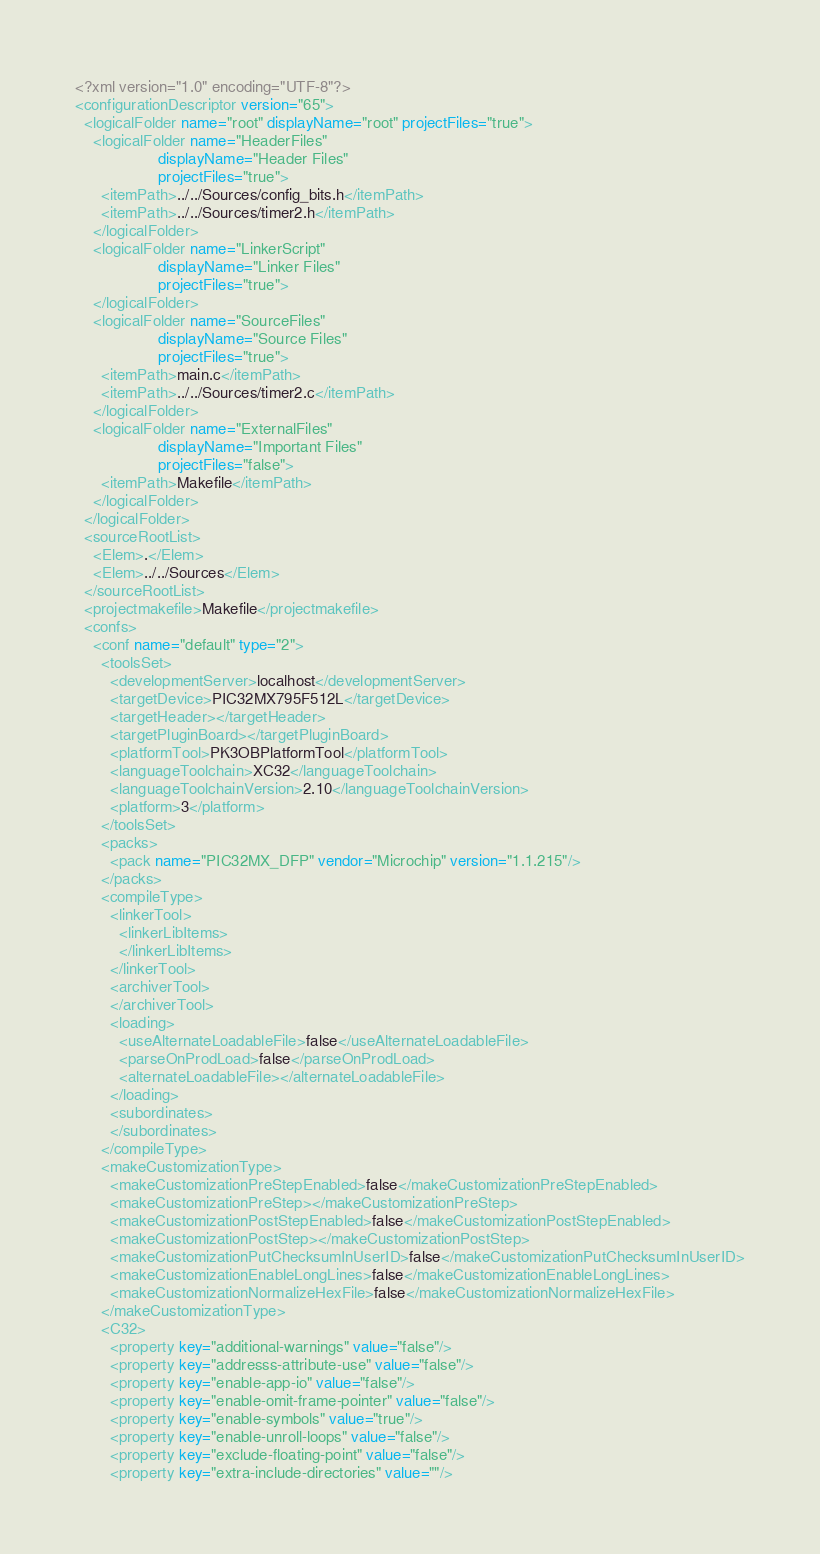<code> <loc_0><loc_0><loc_500><loc_500><_XML_><?xml version="1.0" encoding="UTF-8"?>
<configurationDescriptor version="65">
  <logicalFolder name="root" displayName="root" projectFiles="true">
    <logicalFolder name="HeaderFiles"
                   displayName="Header Files"
                   projectFiles="true">
      <itemPath>../../Sources/config_bits.h</itemPath>
      <itemPath>../../Sources/timer2.h</itemPath>
    </logicalFolder>
    <logicalFolder name="LinkerScript"
                   displayName="Linker Files"
                   projectFiles="true">
    </logicalFolder>
    <logicalFolder name="SourceFiles"
                   displayName="Source Files"
                   projectFiles="true">
      <itemPath>main.c</itemPath>
      <itemPath>../../Sources/timer2.c</itemPath>
    </logicalFolder>
    <logicalFolder name="ExternalFiles"
                   displayName="Important Files"
                   projectFiles="false">
      <itemPath>Makefile</itemPath>
    </logicalFolder>
  </logicalFolder>
  <sourceRootList>
    <Elem>.</Elem>
    <Elem>../../Sources</Elem>
  </sourceRootList>
  <projectmakefile>Makefile</projectmakefile>
  <confs>
    <conf name="default" type="2">
      <toolsSet>
        <developmentServer>localhost</developmentServer>
        <targetDevice>PIC32MX795F512L</targetDevice>
        <targetHeader></targetHeader>
        <targetPluginBoard></targetPluginBoard>
        <platformTool>PK3OBPlatformTool</platformTool>
        <languageToolchain>XC32</languageToolchain>
        <languageToolchainVersion>2.10</languageToolchainVersion>
        <platform>3</platform>
      </toolsSet>
      <packs>
        <pack name="PIC32MX_DFP" vendor="Microchip" version="1.1.215"/>
      </packs>
      <compileType>
        <linkerTool>
          <linkerLibItems>
          </linkerLibItems>
        </linkerTool>
        <archiverTool>
        </archiverTool>
        <loading>
          <useAlternateLoadableFile>false</useAlternateLoadableFile>
          <parseOnProdLoad>false</parseOnProdLoad>
          <alternateLoadableFile></alternateLoadableFile>
        </loading>
        <subordinates>
        </subordinates>
      </compileType>
      <makeCustomizationType>
        <makeCustomizationPreStepEnabled>false</makeCustomizationPreStepEnabled>
        <makeCustomizationPreStep></makeCustomizationPreStep>
        <makeCustomizationPostStepEnabled>false</makeCustomizationPostStepEnabled>
        <makeCustomizationPostStep></makeCustomizationPostStep>
        <makeCustomizationPutChecksumInUserID>false</makeCustomizationPutChecksumInUserID>
        <makeCustomizationEnableLongLines>false</makeCustomizationEnableLongLines>
        <makeCustomizationNormalizeHexFile>false</makeCustomizationNormalizeHexFile>
      </makeCustomizationType>
      <C32>
        <property key="additional-warnings" value="false"/>
        <property key="addresss-attribute-use" value="false"/>
        <property key="enable-app-io" value="false"/>
        <property key="enable-omit-frame-pointer" value="false"/>
        <property key="enable-symbols" value="true"/>
        <property key="enable-unroll-loops" value="false"/>
        <property key="exclude-floating-point" value="false"/>
        <property key="extra-include-directories" value=""/></code> 